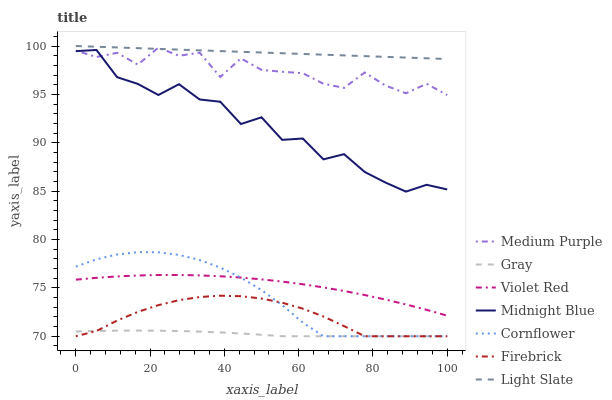Does Gray have the minimum area under the curve?
Answer yes or no. Yes. Does Light Slate have the maximum area under the curve?
Answer yes or no. Yes. Does Violet Red have the minimum area under the curve?
Answer yes or no. No. Does Violet Red have the maximum area under the curve?
Answer yes or no. No. Is Light Slate the smoothest?
Answer yes or no. Yes. Is Midnight Blue the roughest?
Answer yes or no. Yes. Is Violet Red the smoothest?
Answer yes or no. No. Is Violet Red the roughest?
Answer yes or no. No. Does Violet Red have the lowest value?
Answer yes or no. No. Does Light Slate have the highest value?
Answer yes or no. Yes. Does Violet Red have the highest value?
Answer yes or no. No. Is Gray less than Midnight Blue?
Answer yes or no. Yes. Is Medium Purple greater than Firebrick?
Answer yes or no. Yes. Does Gray intersect Midnight Blue?
Answer yes or no. No. 